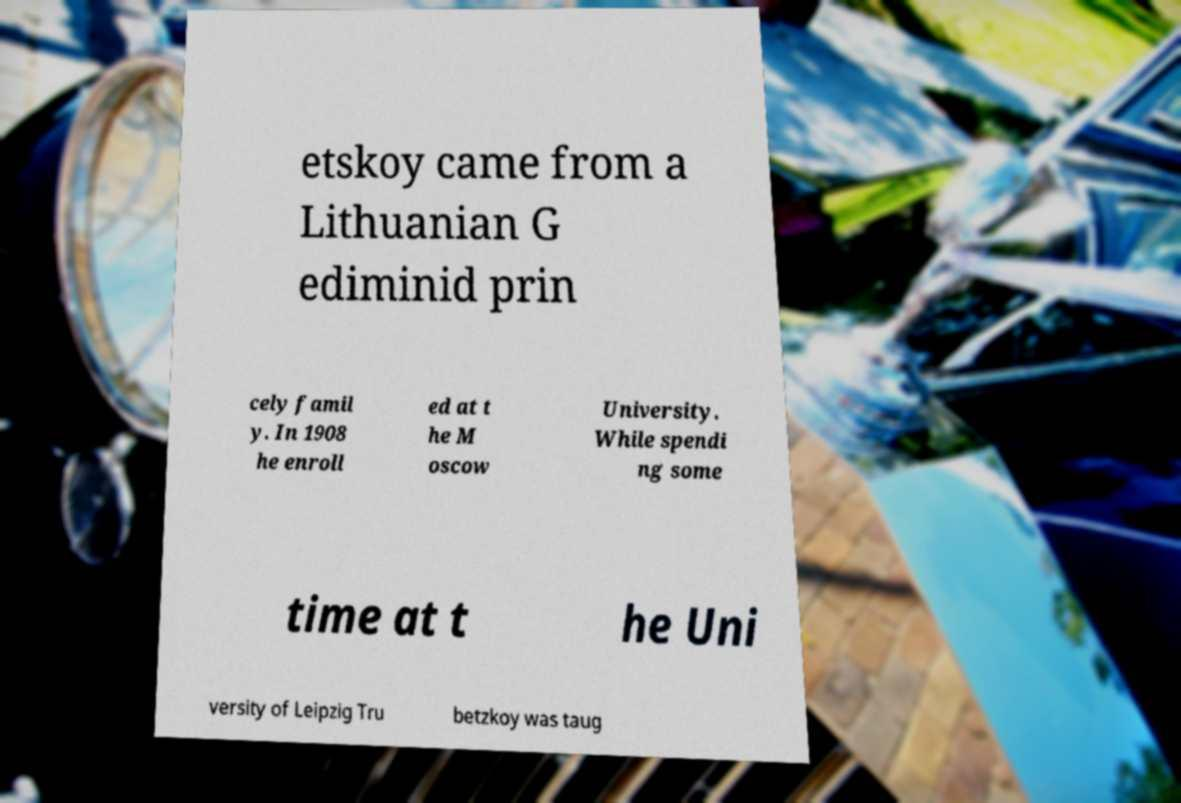Can you accurately transcribe the text from the provided image for me? etskoy came from a Lithuanian G ediminid prin cely famil y. In 1908 he enroll ed at t he M oscow University. While spendi ng some time at t he Uni versity of Leipzig Tru betzkoy was taug 